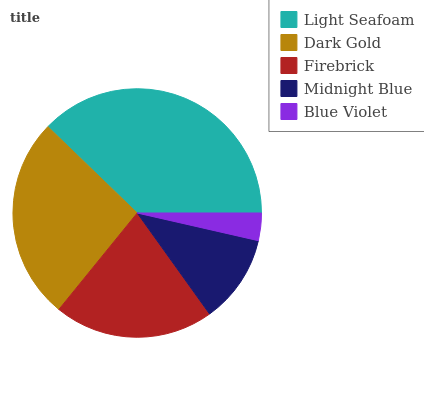Is Blue Violet the minimum?
Answer yes or no. Yes. Is Light Seafoam the maximum?
Answer yes or no. Yes. Is Dark Gold the minimum?
Answer yes or no. No. Is Dark Gold the maximum?
Answer yes or no. No. Is Light Seafoam greater than Dark Gold?
Answer yes or no. Yes. Is Dark Gold less than Light Seafoam?
Answer yes or no. Yes. Is Dark Gold greater than Light Seafoam?
Answer yes or no. No. Is Light Seafoam less than Dark Gold?
Answer yes or no. No. Is Firebrick the high median?
Answer yes or no. Yes. Is Firebrick the low median?
Answer yes or no. Yes. Is Dark Gold the high median?
Answer yes or no. No. Is Midnight Blue the low median?
Answer yes or no. No. 